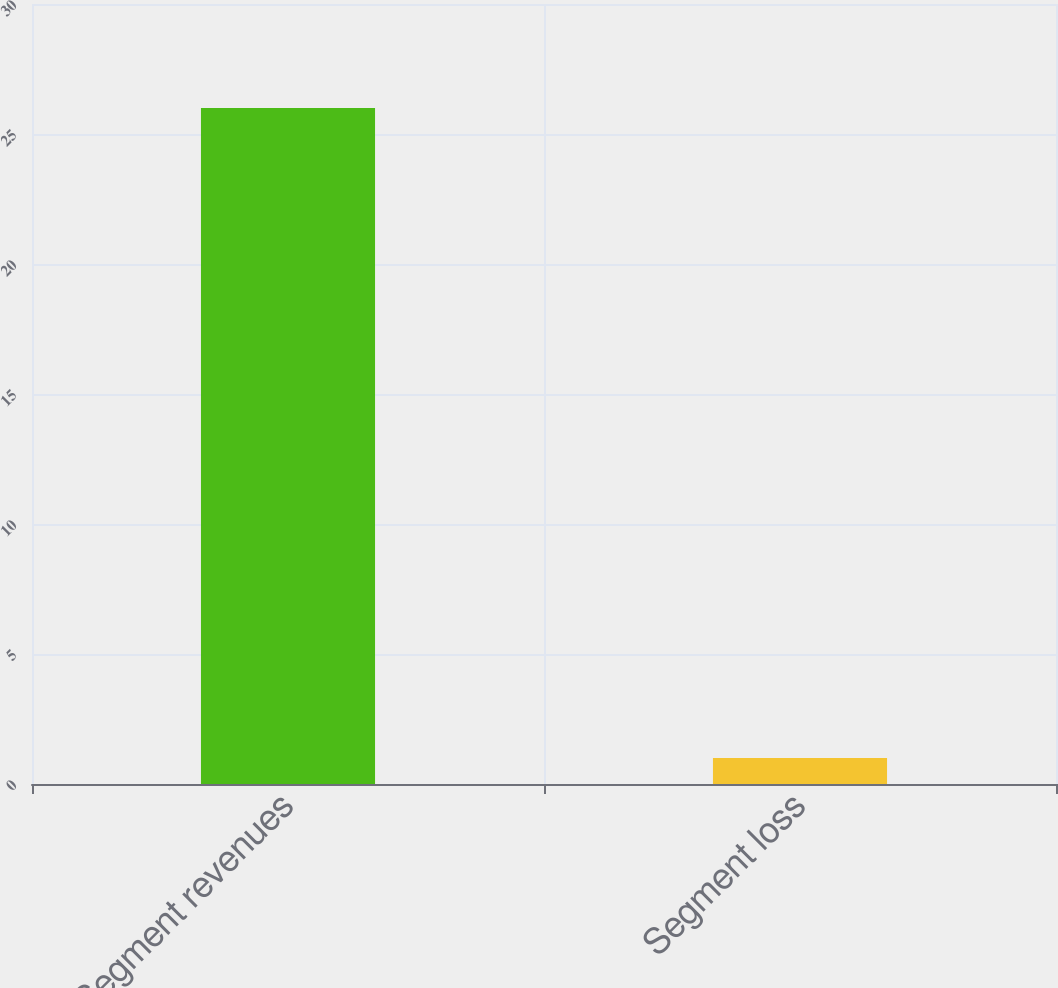Convert chart. <chart><loc_0><loc_0><loc_500><loc_500><bar_chart><fcel>Segment revenues<fcel>Segment loss<nl><fcel>26<fcel>1<nl></chart> 